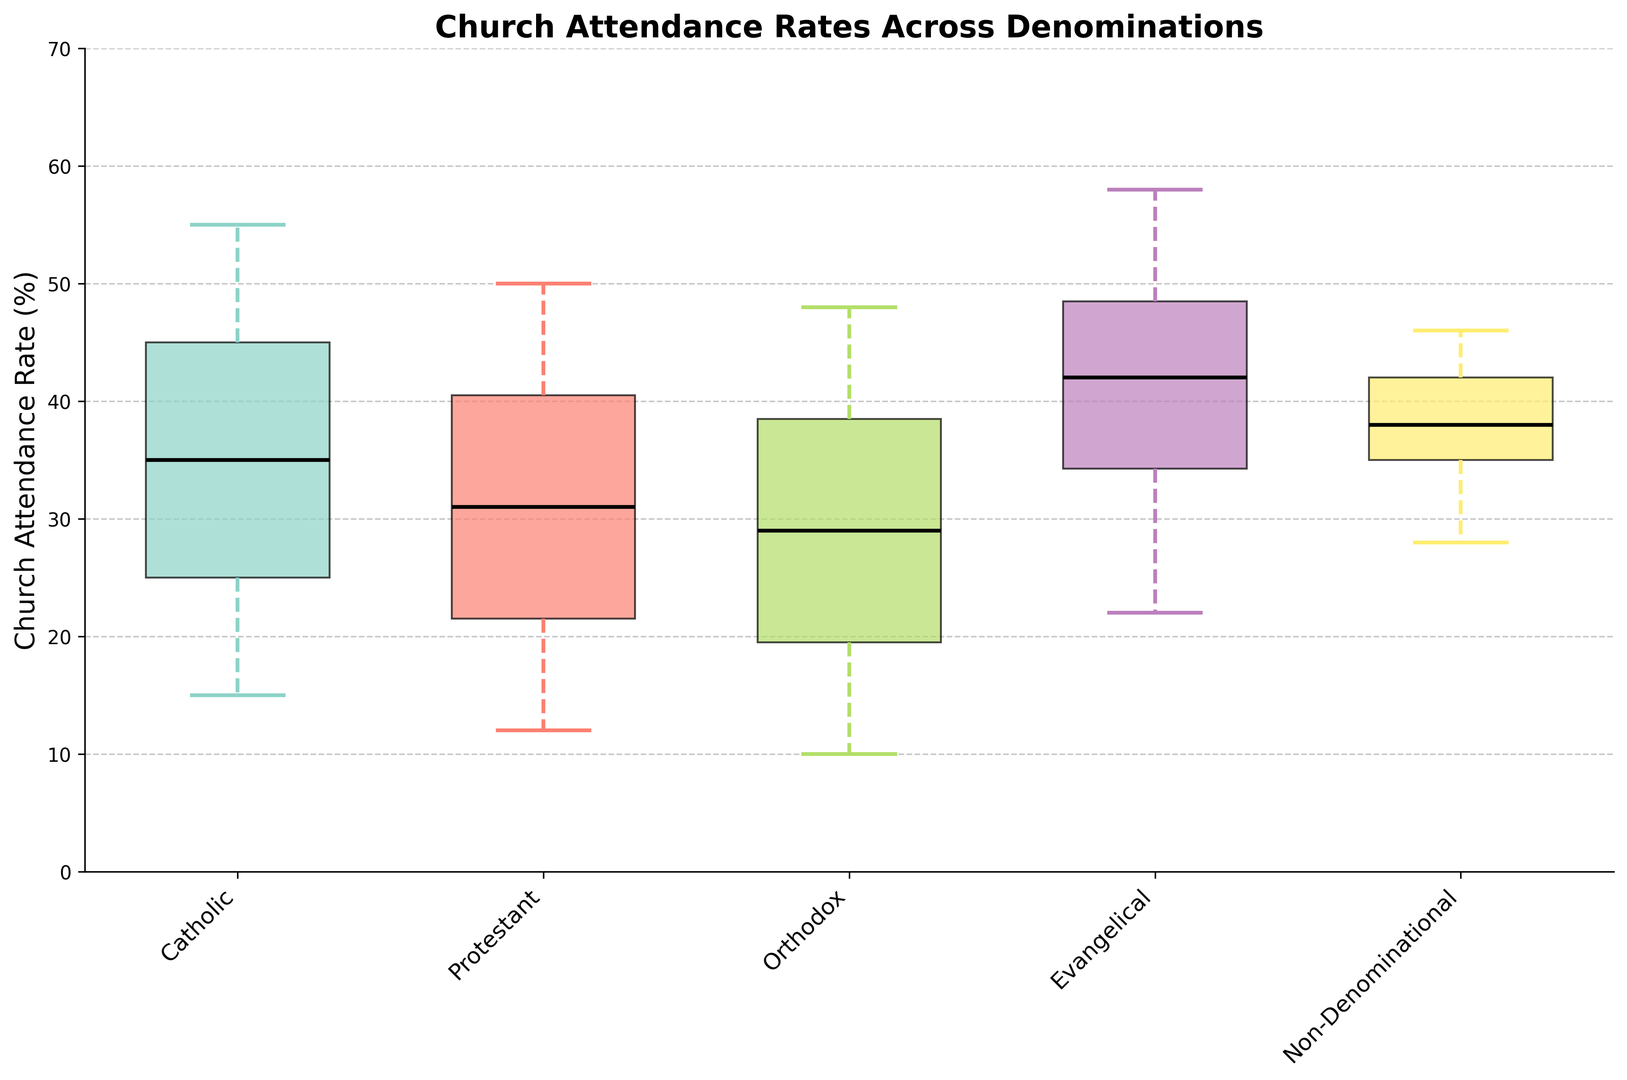Which denomination shows the highest median church attendance rate? To determine this, look at the middle line within each box in the plot, which represents the median. Observe which plot among the denominations has the tallest median line.
Answer: Non-Denominational Which age group has the highest maximum church attendance rate for Catholic denomination? Examine the whiskers (the lines extending from the top of the boxes) of the Catholic denomination box plot. The longest whisker represents the highest attendance rate. Observe the highest point reached among the different age groups.
Answer: 60+ What is the interquartile range (IQR) for the Protestant church attendance rate for the 45-59 age group? First, identify the box plot for Protestants that corresponds to the 45-59 age group. The IQR is the difference between the upper quartile (top edge of the box) and lower quartile (bottom edge of the box).
Answer: 8 Which denomination has the widest range of church attendance rates? To find the widest range, look at the spread between the top and bottom whiskers of each box plot. The wider the spread, the wider the range.
Answer: Catholic Which denomination has the lower median attendance rate, Catholics or Orthodox? Compare the median lines (middle lines within the boxes) of the Catholics and Orthodox denominations. Observe which one is lower.
Answer: Orthodox Which denomination's church attendance rate shows the smallest variation? Look for the smallest box with the shortest whiskers, as it indicates the smallest variation in church attendance rates.
Answer: Non-Denominational Which denomination shows the most significant increase in church attendance rates from 18-29 to 60+ age group? Examine and compare the median values for the 18-29 and 60+ age groups for each denomination. Identify the denomination with the largest increase.
Answer: Catholic What is the median church attendance rate for the Evangelical denomination for the age group 30-44? Find the box plot for Evangelical with the age group 30-44 and observe the middle line within the box. This middle line indicates the median.
Answer: 40 Do Evangelical church attendance rates have more variation for younger (18-29) or older (45-59) group? To compare variation, look at the spread of the boxes and the length of the whiskers for the 18-29 and 45-59 age groups in the Evangelical denomination.
Answer: 18-29 Which denomination's attendance rates are most consistent across all age groups? Consistency is represented by smaller boxes and shorter whiskers across all age groups. Compare the plots for each denomination to identify which shows the least variation.
Answer: Orthodox 